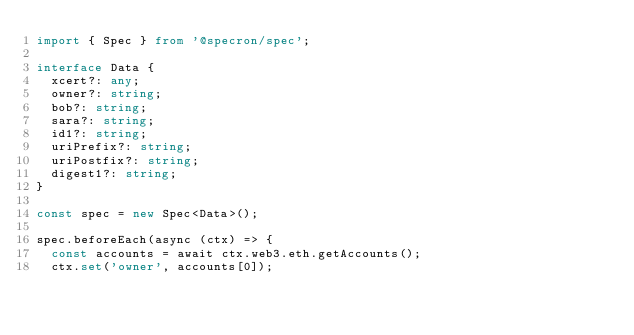<code> <loc_0><loc_0><loc_500><loc_500><_TypeScript_>import { Spec } from '@specron/spec';

interface Data {
  xcert?: any;
  owner?: string;
  bob?: string;
  sara?: string;
  id1?: string;
  uriPrefix?: string;
  uriPostfix?: string;
  digest1?: string;
}

const spec = new Spec<Data>();

spec.beforeEach(async (ctx) => {
  const accounts = await ctx.web3.eth.getAccounts();
  ctx.set('owner', accounts[0]);</code> 